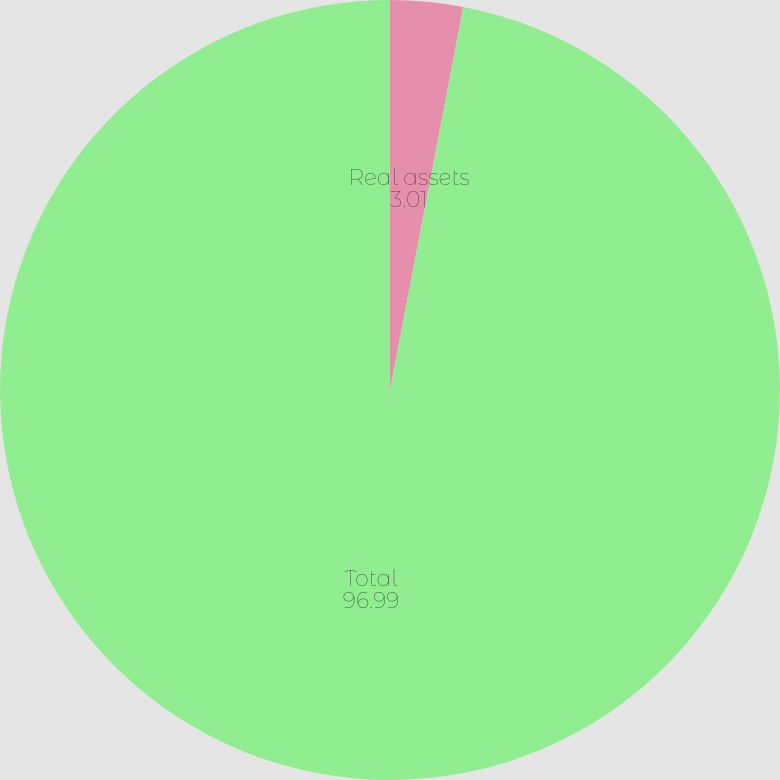Convert chart. <chart><loc_0><loc_0><loc_500><loc_500><pie_chart><fcel>Real assets<fcel>Total<nl><fcel>3.01%<fcel>96.99%<nl></chart> 